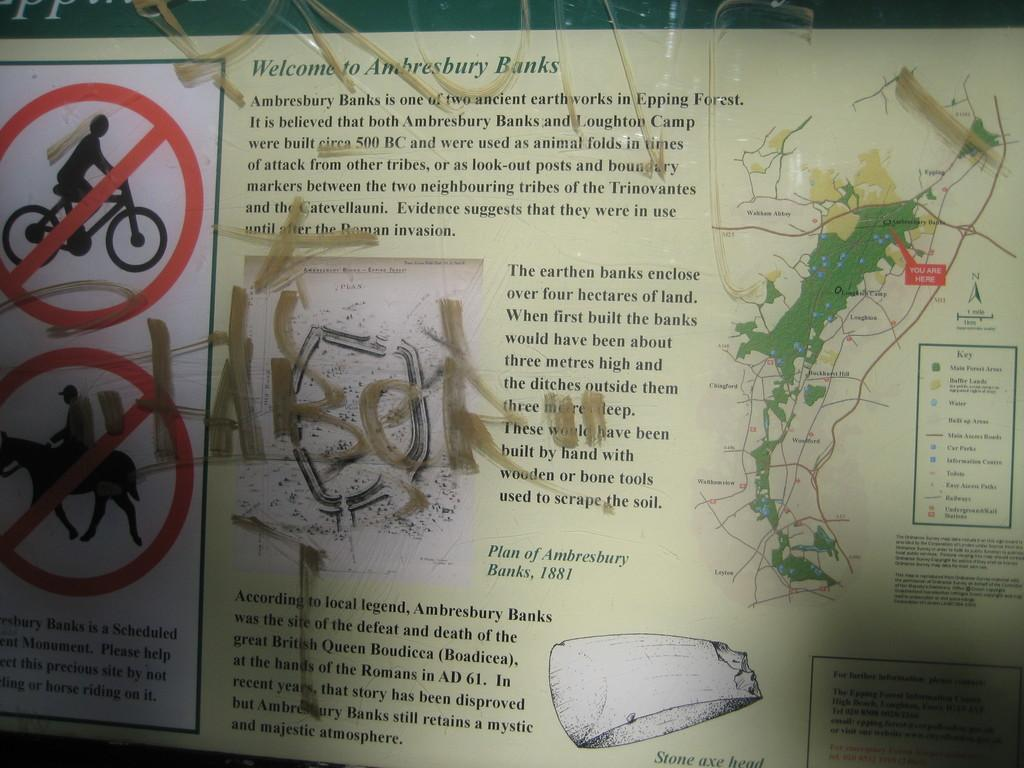What is featured in the image? There is a poster in the image. What can be seen on the poster? The poster has signs on it, writing, and a map. Are there any tomatoes growing on the branches in the image? There are no tomatoes or branches present in the image; it features a poster with signs, writing, and a map. 